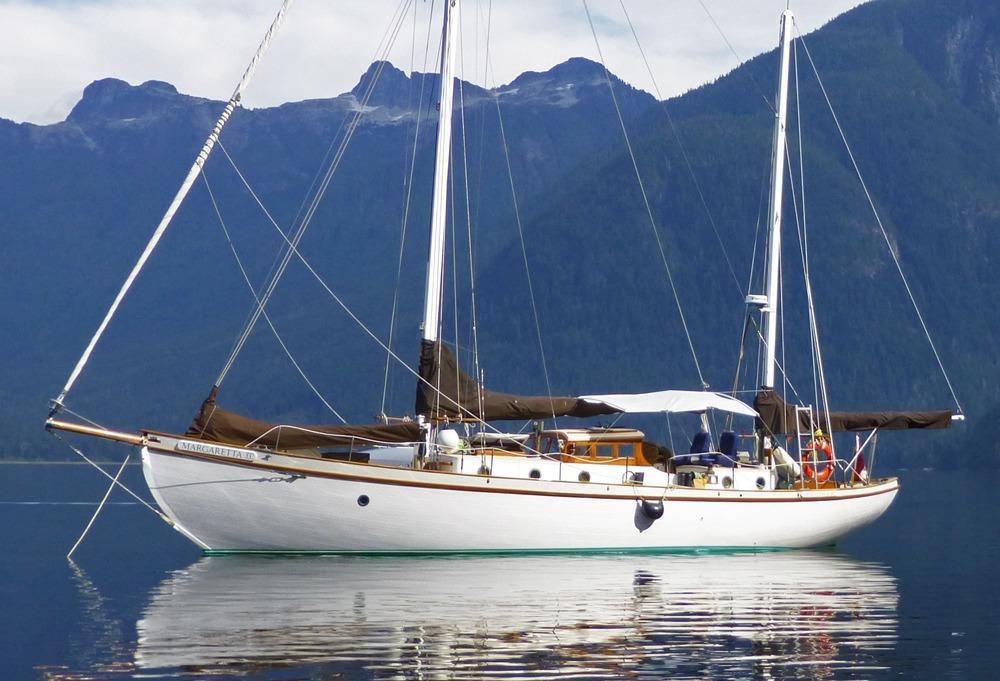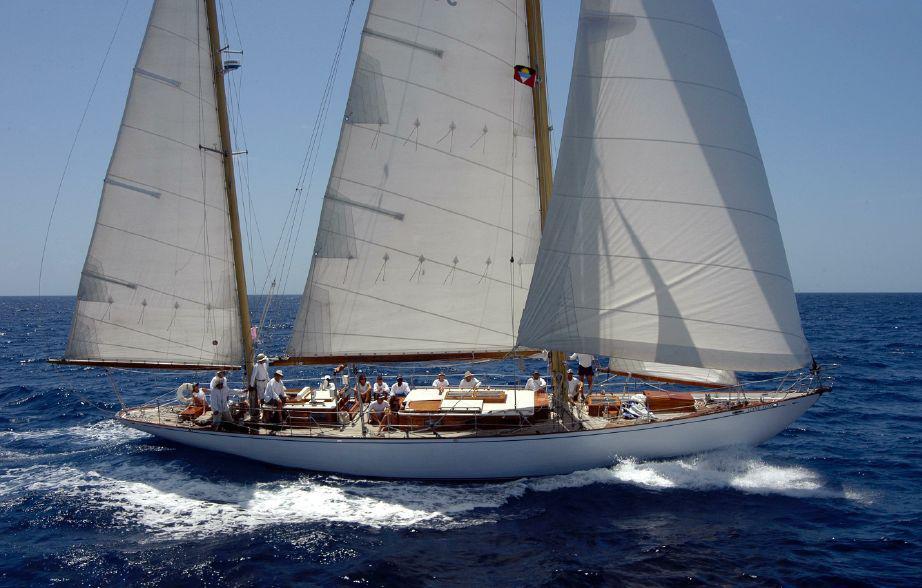The first image is the image on the left, the second image is the image on the right. Considering the images on both sides, is "the boats in the image pair have no sails raised" valid? Answer yes or no. No. The first image is the image on the left, the second image is the image on the right. Examine the images to the left and right. Is the description "There is a ship with at least one sail unfurled." accurate? Answer yes or no. Yes. 